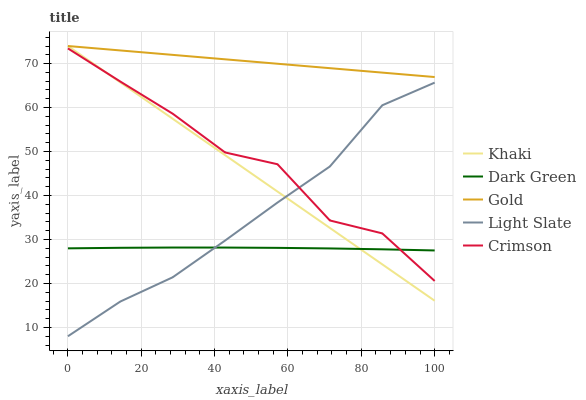Does Dark Green have the minimum area under the curve?
Answer yes or no. Yes. Does Gold have the maximum area under the curve?
Answer yes or no. Yes. Does Crimson have the minimum area under the curve?
Answer yes or no. No. Does Crimson have the maximum area under the curve?
Answer yes or no. No. Is Khaki the smoothest?
Answer yes or no. Yes. Is Crimson the roughest?
Answer yes or no. Yes. Is Crimson the smoothest?
Answer yes or no. No. Is Khaki the roughest?
Answer yes or no. No. Does Light Slate have the lowest value?
Answer yes or no. Yes. Does Crimson have the lowest value?
Answer yes or no. No. Does Gold have the highest value?
Answer yes or no. Yes. Does Crimson have the highest value?
Answer yes or no. No. Is Dark Green less than Gold?
Answer yes or no. Yes. Is Gold greater than Light Slate?
Answer yes or no. Yes. Does Light Slate intersect Crimson?
Answer yes or no. Yes. Is Light Slate less than Crimson?
Answer yes or no. No. Is Light Slate greater than Crimson?
Answer yes or no. No. Does Dark Green intersect Gold?
Answer yes or no. No. 